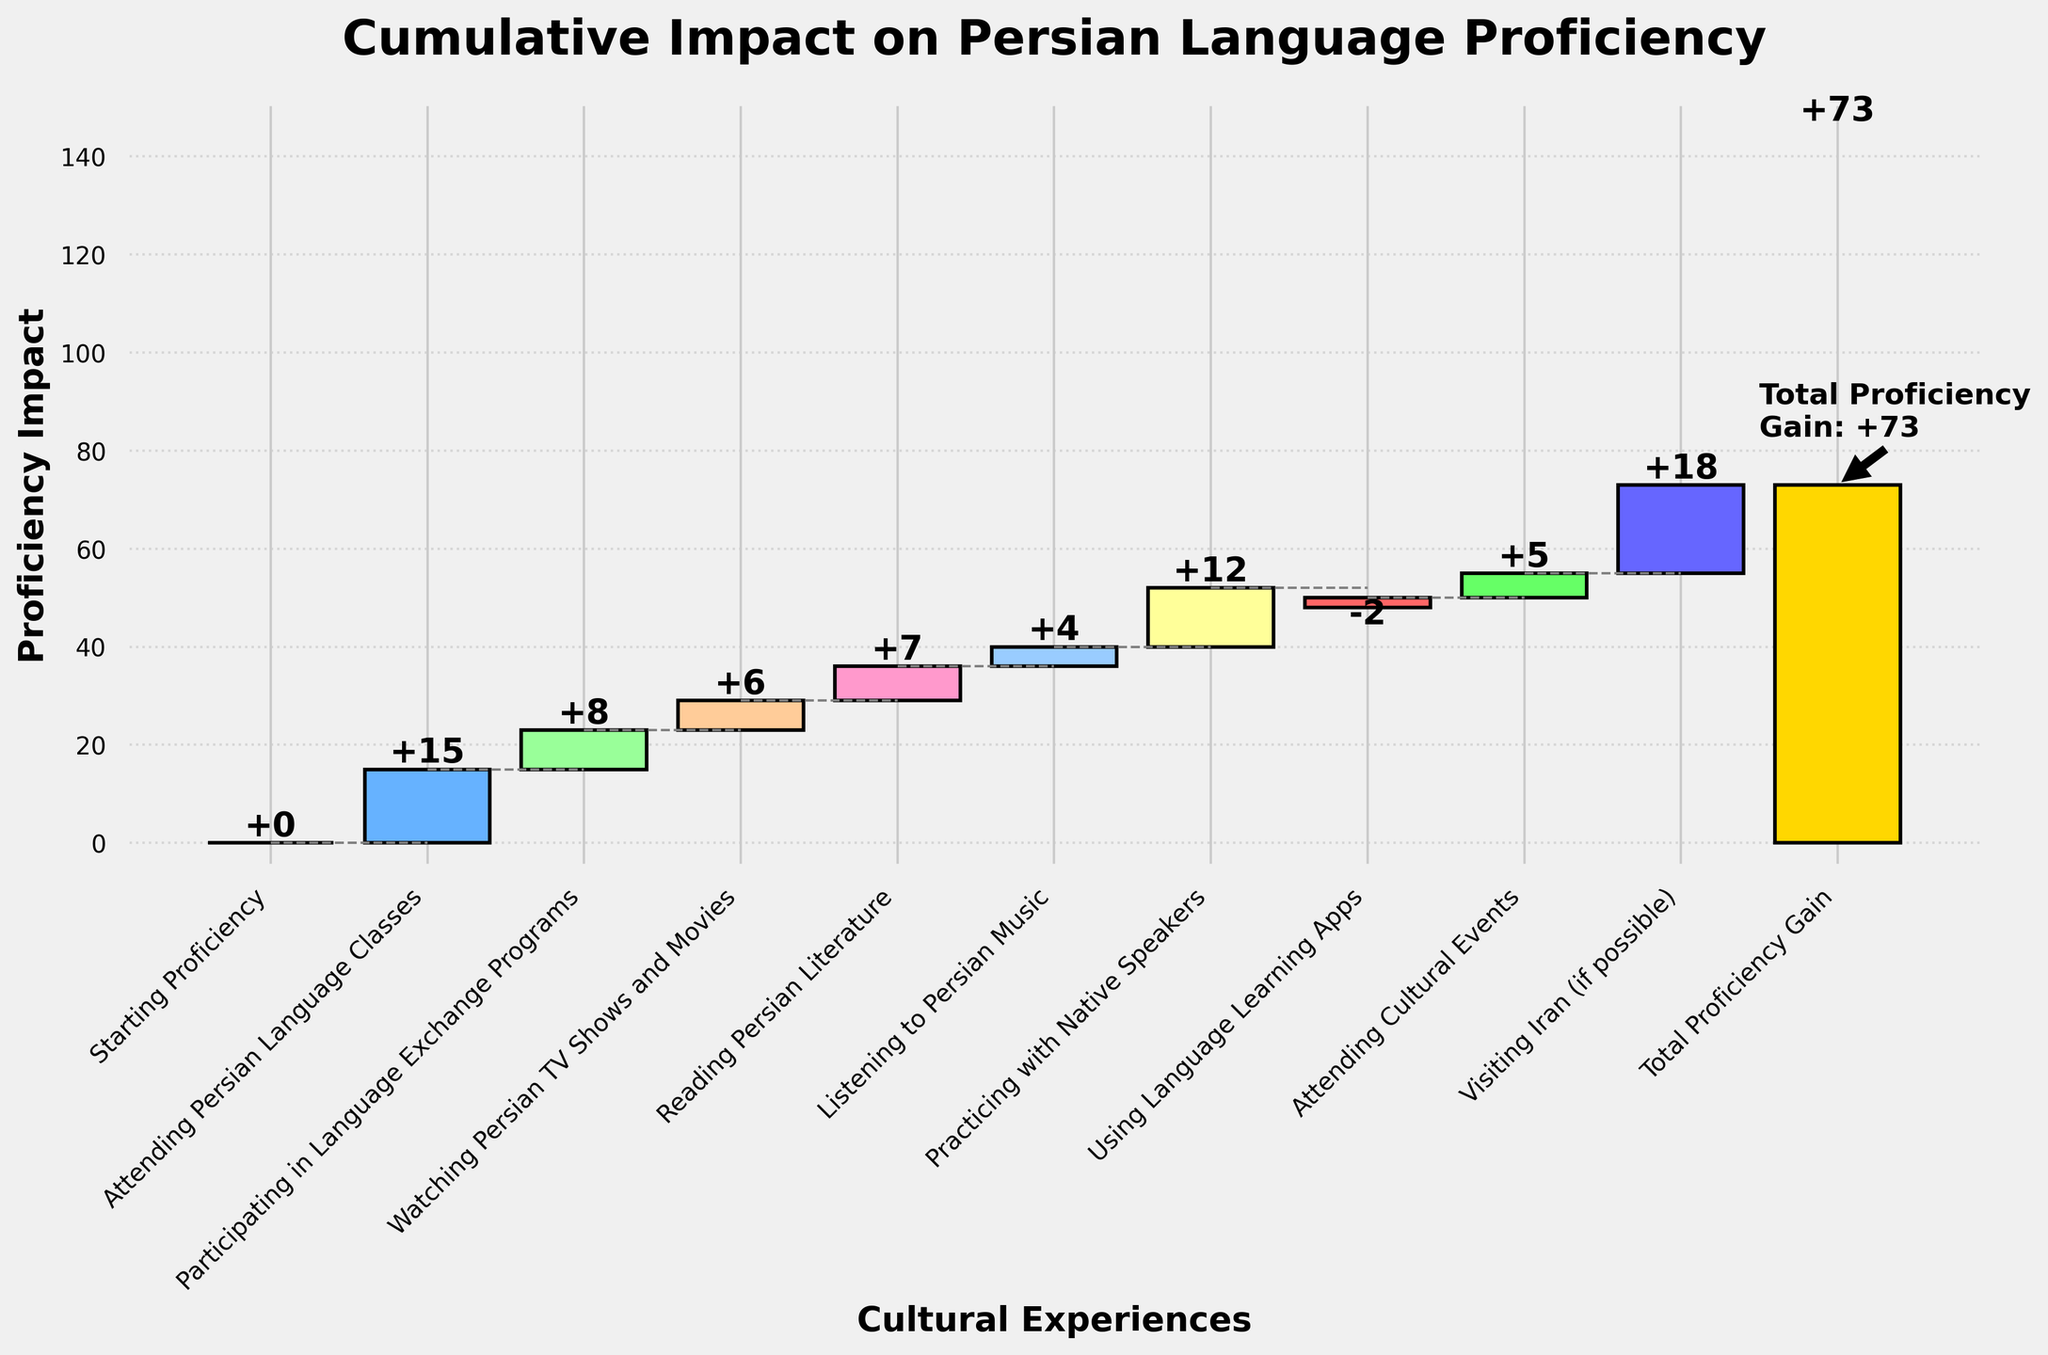What is the title of the chart? The title of the chart is shown at the top.
Answer: Cumulative Impact on Persian Language Proficiency What is the starting proficiency impact? The starting proficiency impact value is the first bar, labeled "Starting Proficiency."
Answer: 0 What's the total proficiency gain after all the cultural experiences? The total proficiency gain is represented by the last bar, labeled "Total Proficiency Gain."
Answer: 73 Which cultural experience contributes the most to Persian language proficiency? Find the cultural experience with the highest individual impact value among the bars. "Visiting Iran (if possible)" has the highest bar.
Answer: Visiting Iran (if possible) How many cultural experiences have a positive impact on proficiency? Count the number of bars that have positive impacts, i.e., bars that are above zero.
Answer: 8 What's the cumulative impact before "Using Language Learning Apps"? Add up all the impacts of previous categories before "Using Language Learning Apps": 15 (Classes) + 8 (Programs) + 6 (TV Shows) + 7 (Literature) + 4 (Music) + 12 (Native Speakers) = 52
Answer: 52 Which cultural experience negatively impacts proficiency, and by how much? Identify the bar with a negative impact: "Using Language Learning Apps," which is -2.
Answer: Using Language Learning Apps, -2 How much does "Practicing with Native Speakers" contribute to proficiency? Look at the impact value of "Practicing with Native Speakers."
Answer: 12 How does the impact of "Reading Persian Literature" compare to "Watching Persian TV Shows and Movies"? Compare the heights of their bars: "Reading Persian Literature" has 7, and "Watching Persian TV Shows and Movies" has 6.
Answer: Reading Persian Literature has a higher impact by 1 What is the combined impact of "Attending Cultural Events" and "Listening to Persian Music"? Sum the impacts: 5 (Cultural Events) + 4 (Music) = 9
Answer: 9 